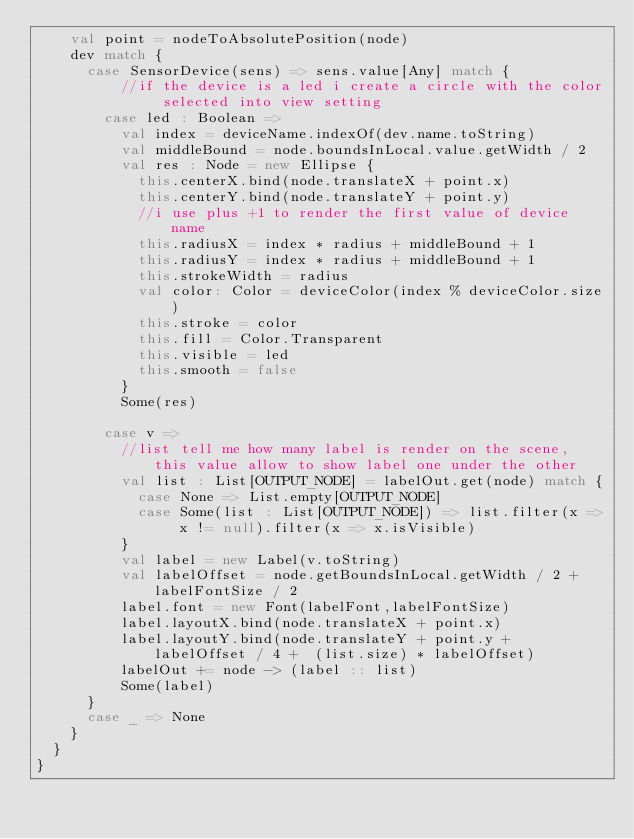<code> <loc_0><loc_0><loc_500><loc_500><_Scala_>    val point = nodeToAbsolutePosition(node)
    dev match {
      case SensorDevice(sens) => sens.value[Any] match {
          //if the device is a led i create a circle with the color selected into view setting
        case led : Boolean =>
          val index = deviceName.indexOf(dev.name.toString)
          val middleBound = node.boundsInLocal.value.getWidth / 2
          val res : Node = new Ellipse {
            this.centerX.bind(node.translateX + point.x)
            this.centerY.bind(node.translateY + point.y)
            //i use plus +1 to render the first value of device name
            this.radiusX = index * radius + middleBound + 1
            this.radiusY = index * radius + middleBound + 1
            this.strokeWidth = radius
            val color: Color = deviceColor(index % deviceColor.size)
            this.stroke = color
            this.fill = Color.Transparent
            this.visible = led
            this.smooth = false
          }
          Some(res)

        case v =>
          //list tell me how many label is render on the scene, this value allow to show label one under the other
          val list : List[OUTPUT_NODE] = labelOut.get(node) match {
            case None => List.empty[OUTPUT_NODE]
            case Some(list : List[OUTPUT_NODE]) => list.filter(x => x != null).filter(x => x.isVisible)
          }
          val label = new Label(v.toString)
          val labelOffset = node.getBoundsInLocal.getWidth / 2 + labelFontSize / 2
          label.font = new Font(labelFont,labelFontSize)
          label.layoutX.bind(node.translateX + point.x)
          label.layoutY.bind(node.translateY + point.y + labelOffset / 4 +  (list.size) * labelOffset)
          labelOut += node -> (label :: list)
          Some(label)
      }
      case _ => None
    }
  }
}
</code> 